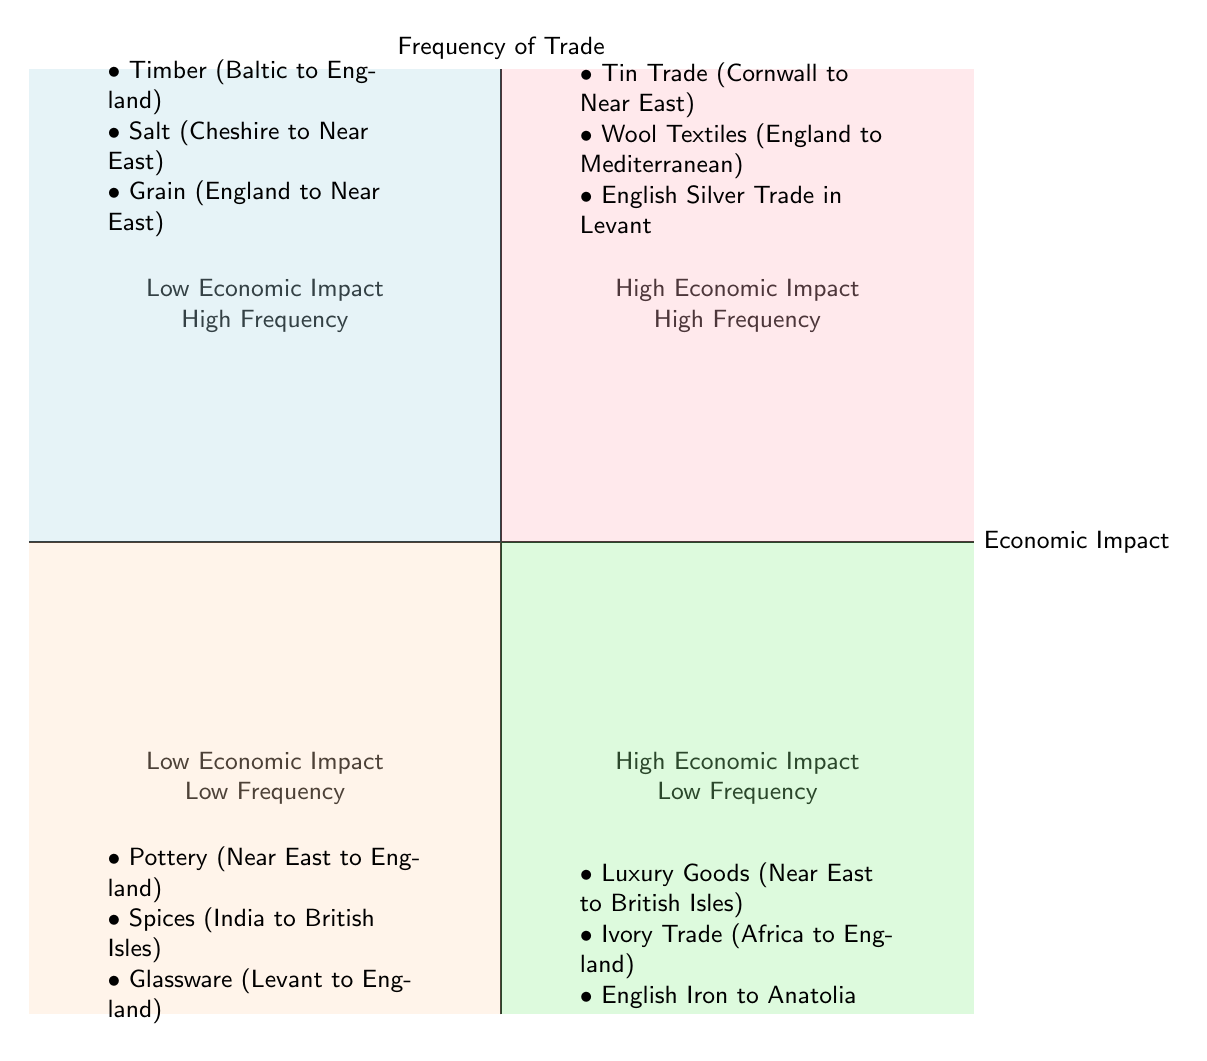What commodities are in the "High Economic Impact - High Frequency" quadrant? This quadrant contains three elements, which are listed: Tin Trade from Cornwall to the Near East, Wool Textiles from England to the Mediterranean, and English Silver Trade in Levant.
Answer: Tin Trade from Cornwall to the Near East, Wool Textiles from England to the Mediterranean, English Silver Trade in Levant How many trade routes are listed in the "Low Economic Impact - Low Frequency" quadrant? There are three trade routes mentioned in this quadrant: Pottery from the Near East to England, Spices from India to British Isles, and Glassware from Levant to England.
Answer: 3 Which quadrant contains the "Luxury Goods from the Near East to British Isles"? The provided information places the "Luxury Goods from the Near East to British Isles" in the "High Economic Impact - Low Frequency" quadrant, where goods with significant economic effects but lesser trading frequency are categorized.
Answer: High Economic Impact - Low Frequency What types of commodities are found in the "Low Economic Impact - High Frequency" quadrant? The three elements here are timber from the Baltic to England, salt from Cheshire to the Near East, and grain from England to the Near East. Together, these represent commodities frequently traded but with lower economic impact.
Answer: Timber, Salt, Grain In which quadrant is "English Iron to Anatolia" located? The "English Iron to Anatolia" falls in the "High Economic Impact - Low Frequency" quadrant, indicating that, while it significantly affects the economy, it is less frequently traded compared to other goods.
Answer: High Economic Impact - Low Frequency 